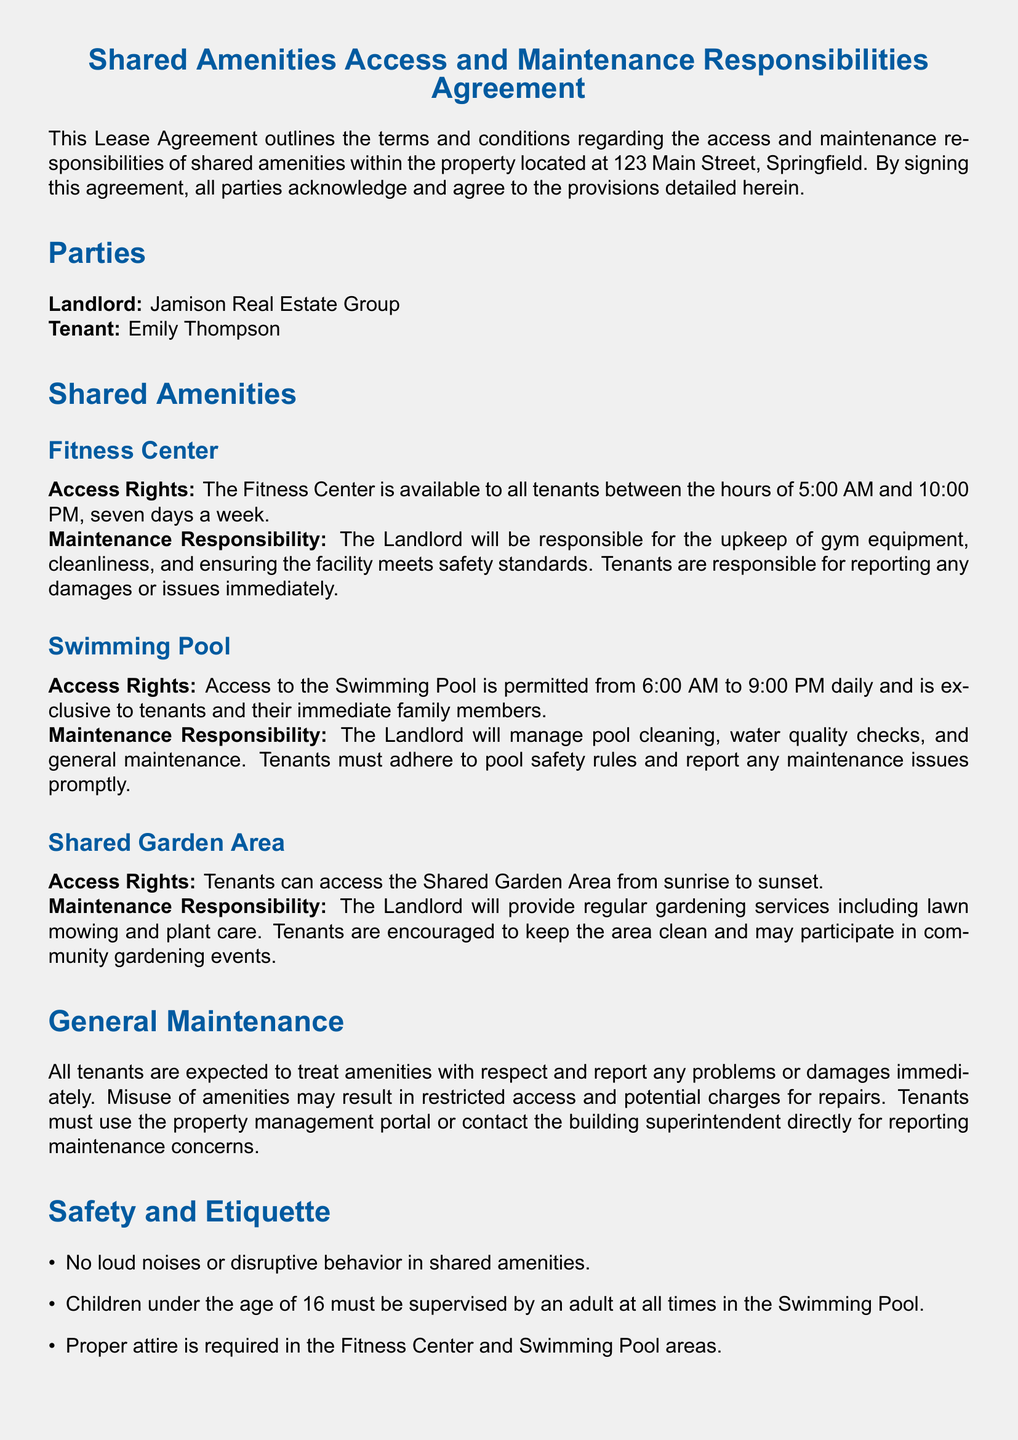What are the access hours for the Fitness Center? The access hours for the Fitness Center are specified between 5:00 AM and 10:00 PM, seven days a week.
Answer: 5:00 AM to 10:00 PM Who is responsible for the maintenance of the Swimming Pool? The document states that the Landlord will manage pool cleaning, water quality checks, and general maintenance.
Answer: Landlord What is the access time for the Swimming Pool? The access time for the Swimming Pool is permitted from 6:00 AM to 9:00 PM daily.
Answer: 6:00 AM to 9:00 PM What must tenants do if they see a maintenance issue? The document indicates that tenants must report any damages or issues immediately for all amenities.
Answer: Report immediately What is the owner of the property? The document lists the name providing lease is Jamison Real Estate Group.
Answer: Jamison Real Estate Group What is required attire in the Fitness Center? The document states that proper attire is required in the Fitness Center and Swimming Pool areas.
Answer: Proper attire What behavior is prohibited in shared amenities? The document mentions that no loud noises or disruptive behavior is allowed in shared amenities.
Answer: Loud noises What age must children be supervised by an adult in the Swimming Pool? The agreement specifies children under the age of 16 must be supervised by an adult at all times.
Answer: Under 16 What must tenants do to keep the Shared Garden Area clean? The document encourages tenants to keep the area clean and may participate in community gardening events.
Answer: Keep the area clean 